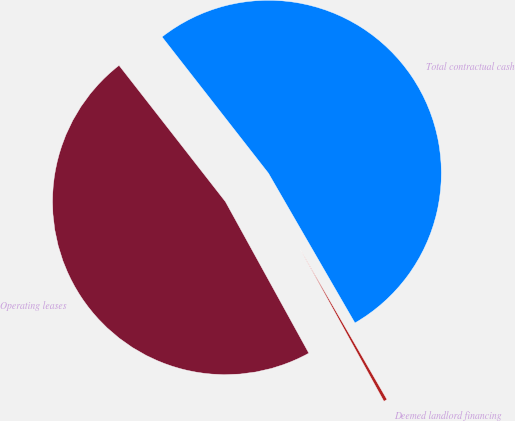<chart> <loc_0><loc_0><loc_500><loc_500><pie_chart><fcel>Operating leases<fcel>Deemed landlord financing<fcel>Total contractual cash<nl><fcel>47.46%<fcel>0.33%<fcel>52.21%<nl></chart> 